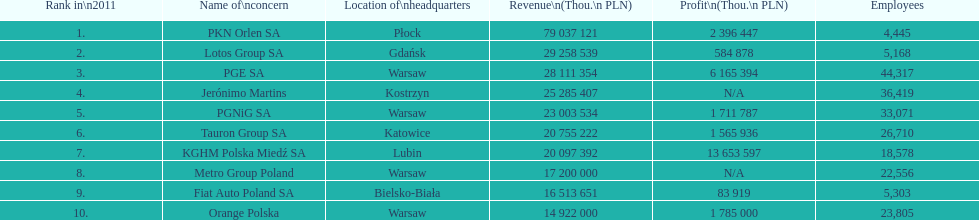Which business had the greatest earnings? PKN Orlen SA. 